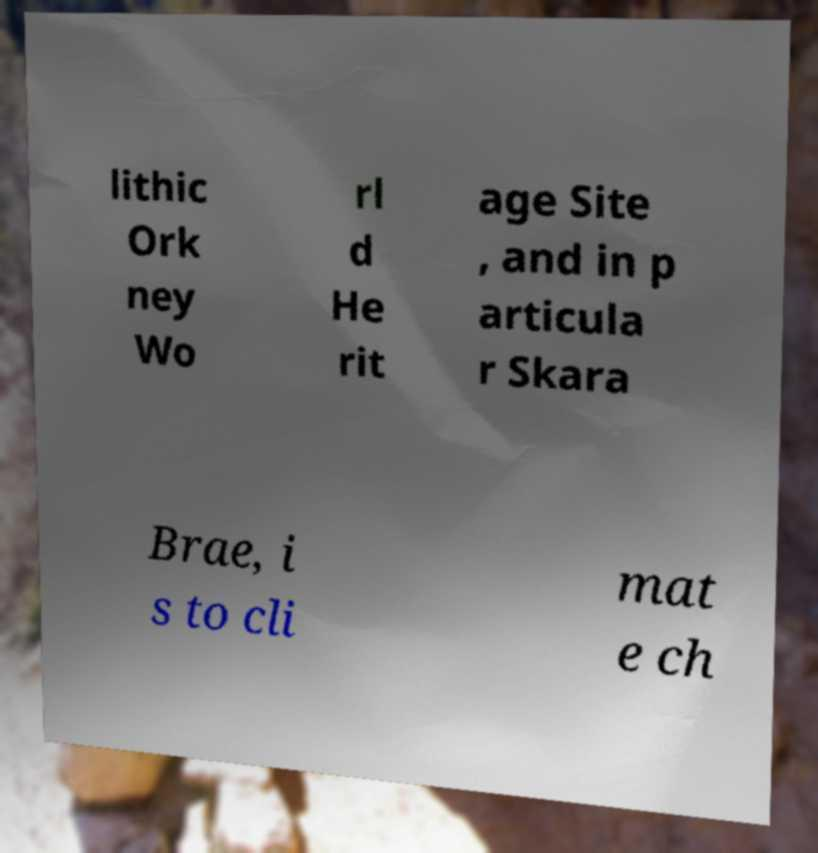I need the written content from this picture converted into text. Can you do that? lithic Ork ney Wo rl d He rit age Site , and in p articula r Skara Brae, i s to cli mat e ch 